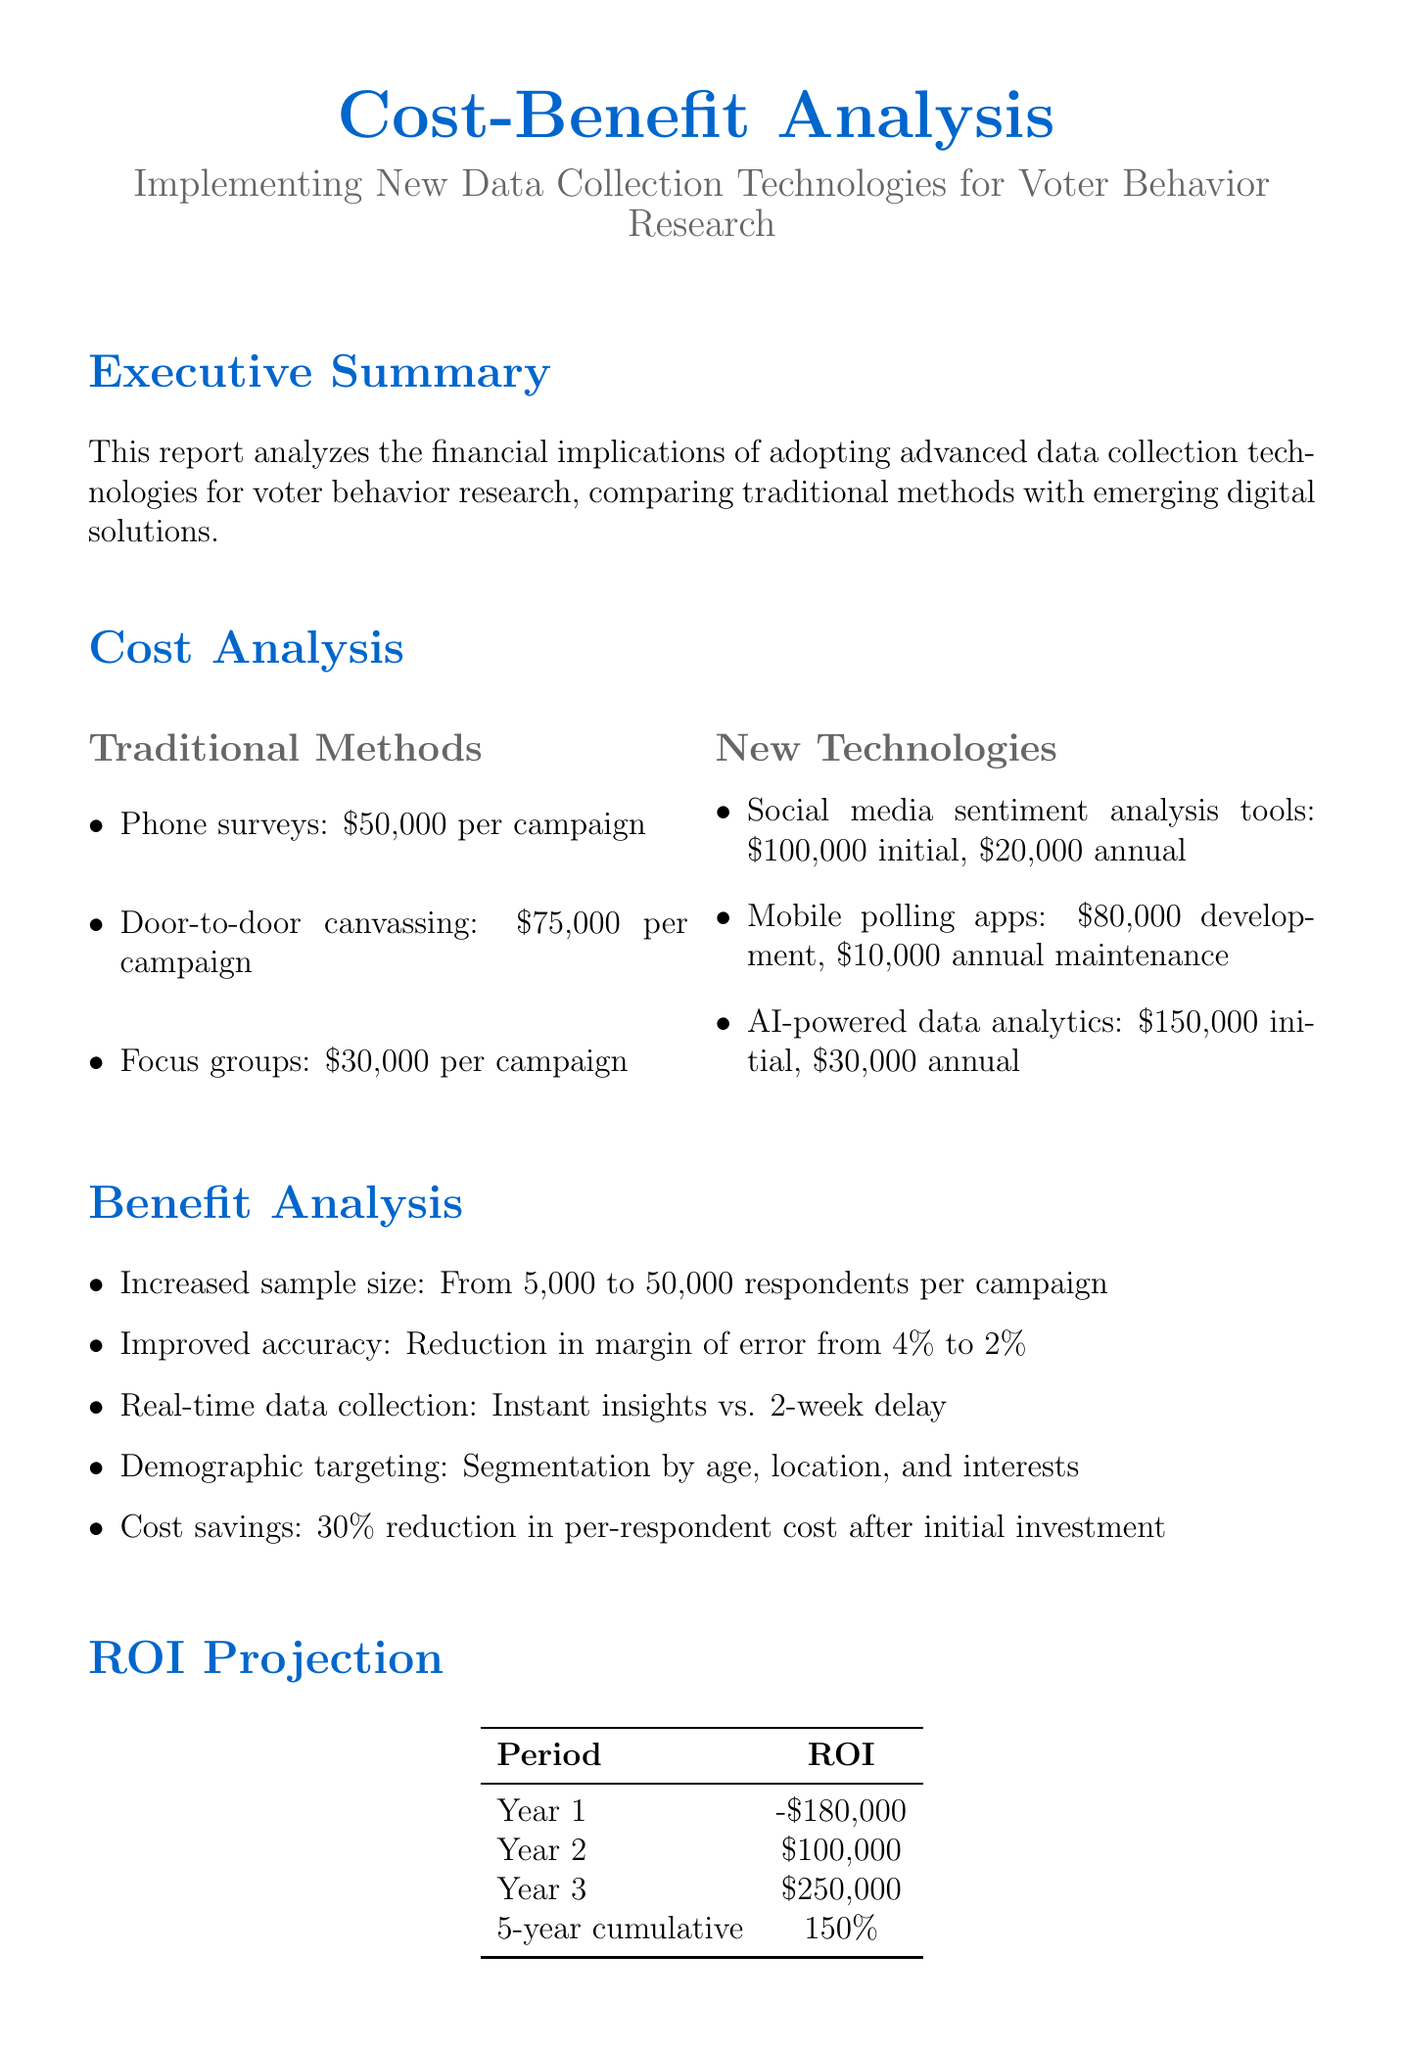What is the title of the report? The title of the report is explicitly stated at the beginning, which is "Cost-Benefit Analysis: Implementing New Data Collection Technologies for Voter Behavior Research."
Answer: Cost-Benefit Analysis: Implementing New Data Collection Technologies for Voter Behavior Research How much does door-to-door canvassing cost per campaign? The cost analysis section provides specific funding amounts for traditional methods, including door-to-door canvassing at $75,000.
Answer: $75,000 What is the benefit of using new technologies in terms of sample size? The benefit analysis states that using new technologies increases the sample size from 5,000 to 50,000 respondents per campaign.
Answer: From 5,000 to 50,000 respondents What is the margin of error reduction achieved by implementing new technologies? The document mentions that the margin of error can be reduced from 4% to 2% when utilizing new technologies.
Answer: From 4% to 2% What is the total initial investment required for AI-powered data analytics? The cost analysis lists the initial investment needed for AI-powered data analytics as $150,000.
Answer: $150,000 What is the projected ROI for Year 3? The ROI projection provides specific financial outcomes and states that the ROI for Year 3 is $250,000.
Answer: $250,000 What is one of the risk factors mentioned in the report? The report identifies data privacy concerns and compliance with regulations as one of the risk factors associated with new data collection technologies.
Answer: Data privacy concerns What is the recommendation for implementing new technologies? The recommendation section advises starting implementation gradually, specifically mentioning social media sentiment analysis and mobile polling apps.
Answer: Gradually, starting with social media sentiment analysis and mobile polling apps What is the annual maintenance cost for mobile polling apps? The cost analysis details the annual maintenance cost for mobile polling apps at $10,000.
Answer: $10,000 